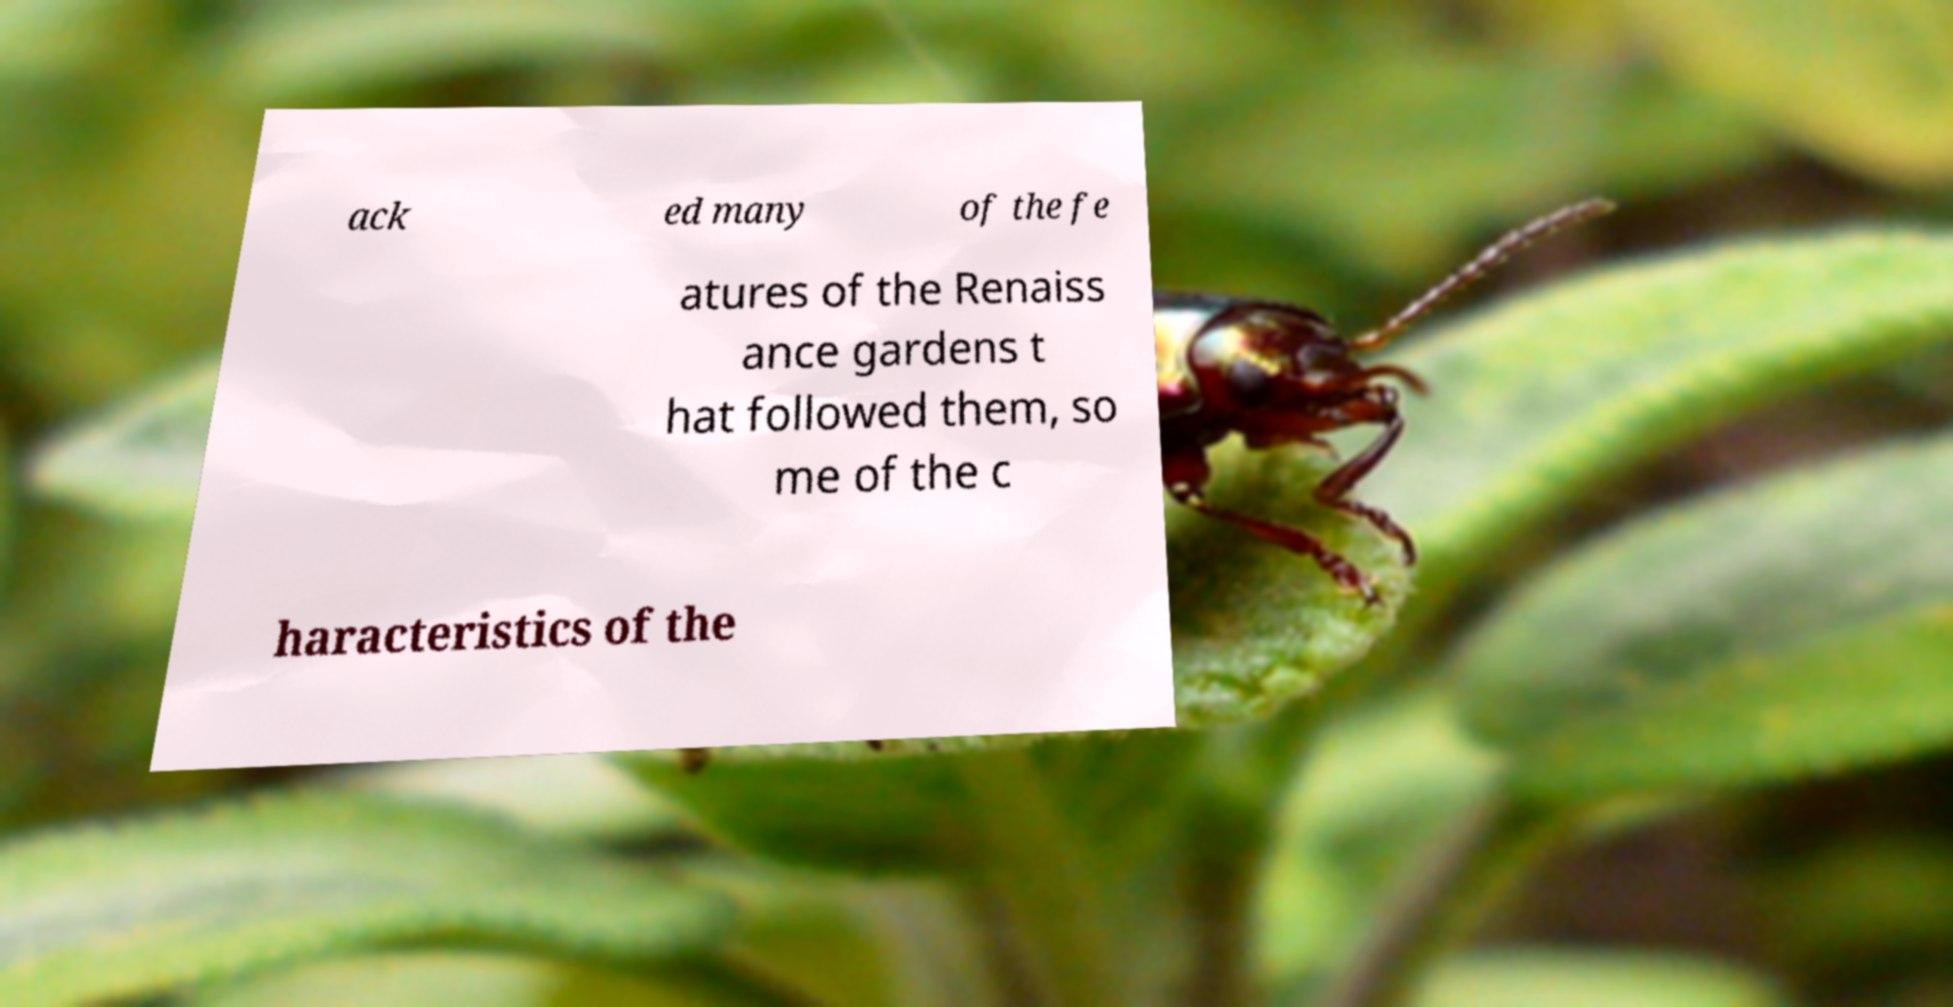What messages or text are displayed in this image? I need them in a readable, typed format. ack ed many of the fe atures of the Renaiss ance gardens t hat followed them, so me of the c haracteristics of the 